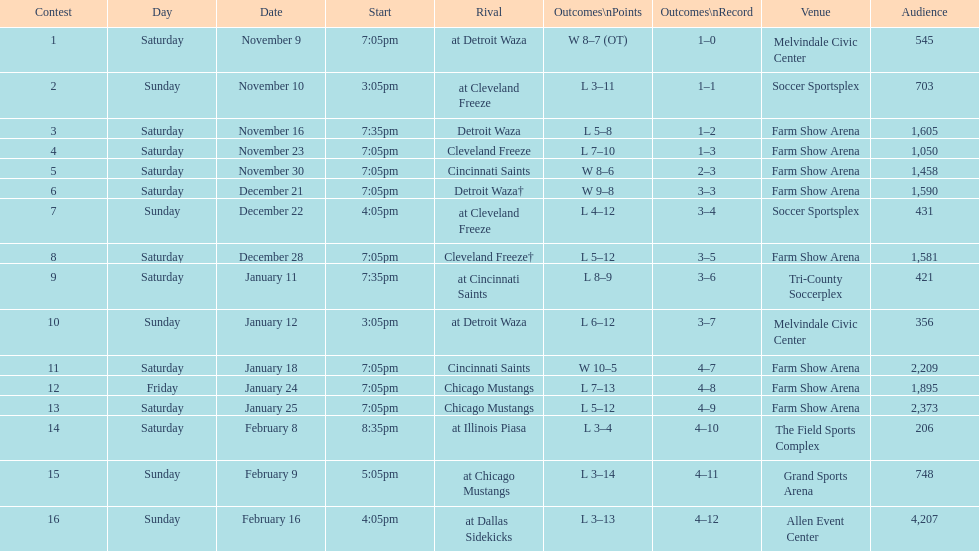Which opponent is listed first in the table? Detroit Waza. 